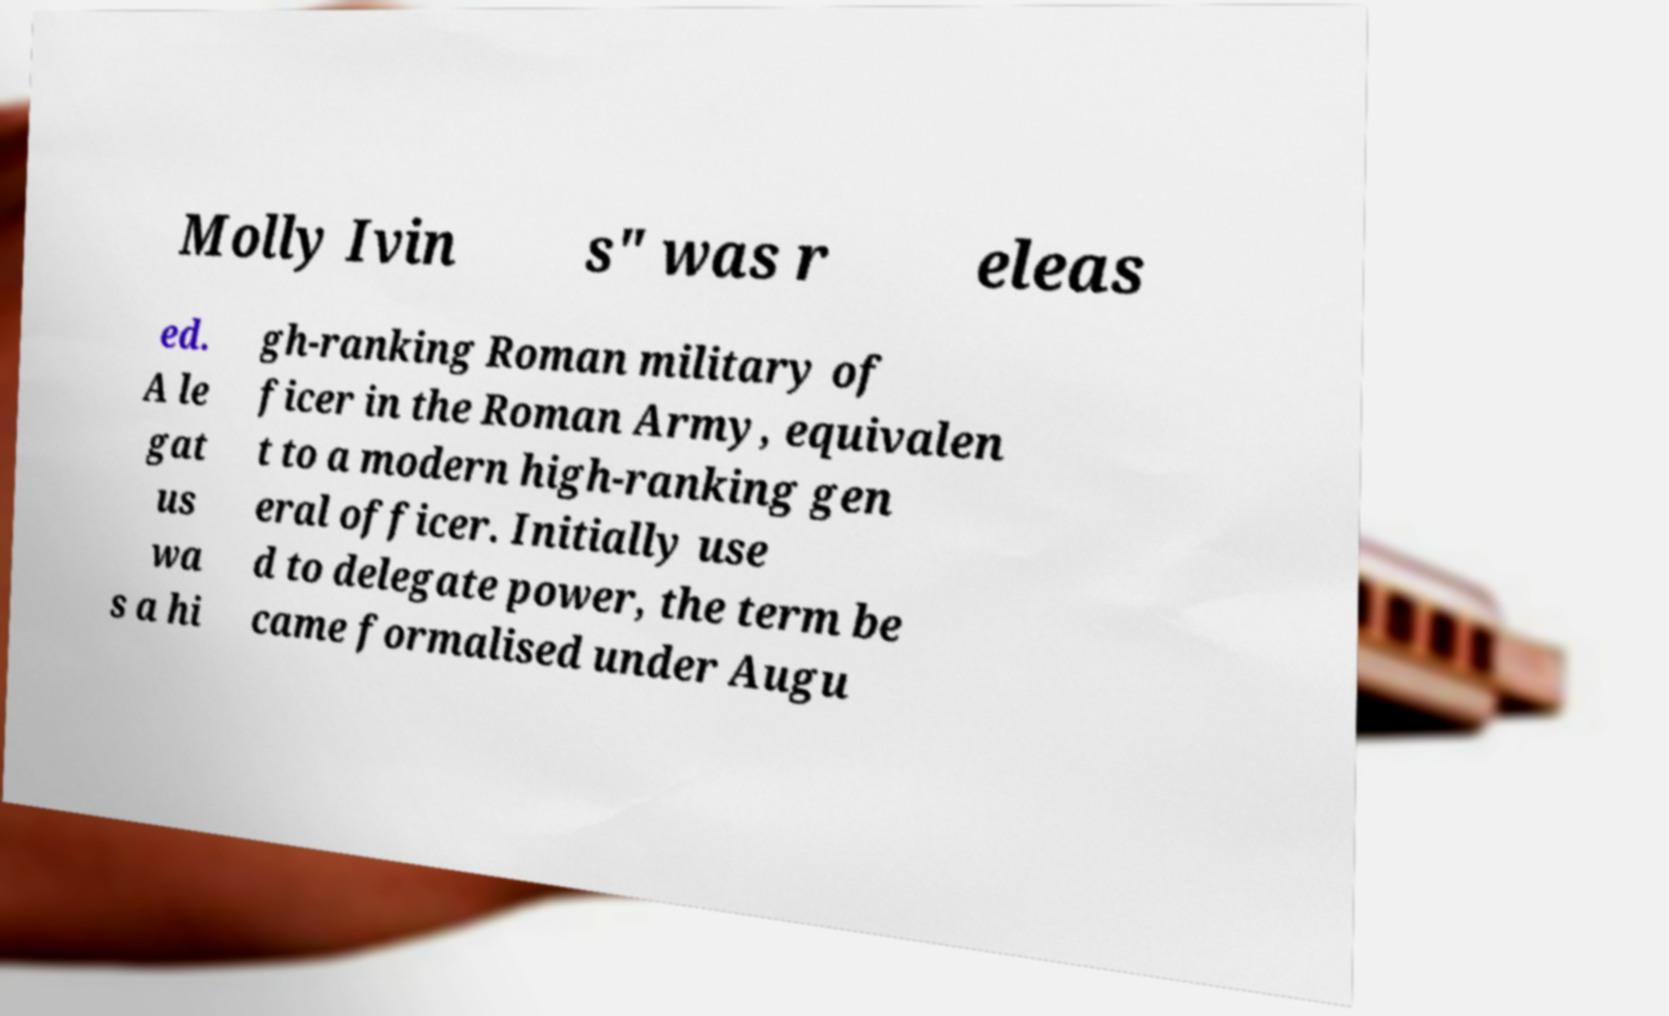Can you accurately transcribe the text from the provided image for me? Molly Ivin s" was r eleas ed. A le gat us wa s a hi gh-ranking Roman military of ficer in the Roman Army, equivalen t to a modern high-ranking gen eral officer. Initially use d to delegate power, the term be came formalised under Augu 